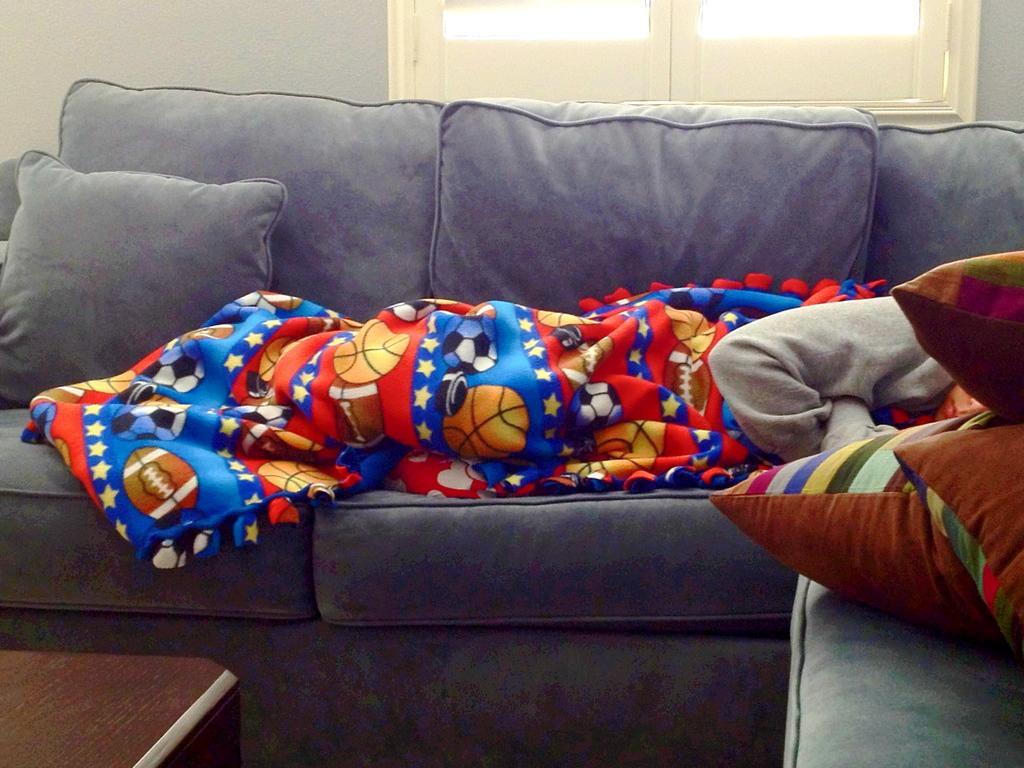Could you give a brief overview of what you see in this image? In this picture we can see a sofa with pillows, bed sheet on it and aside to this we have a table and in background we can see wall, window. 